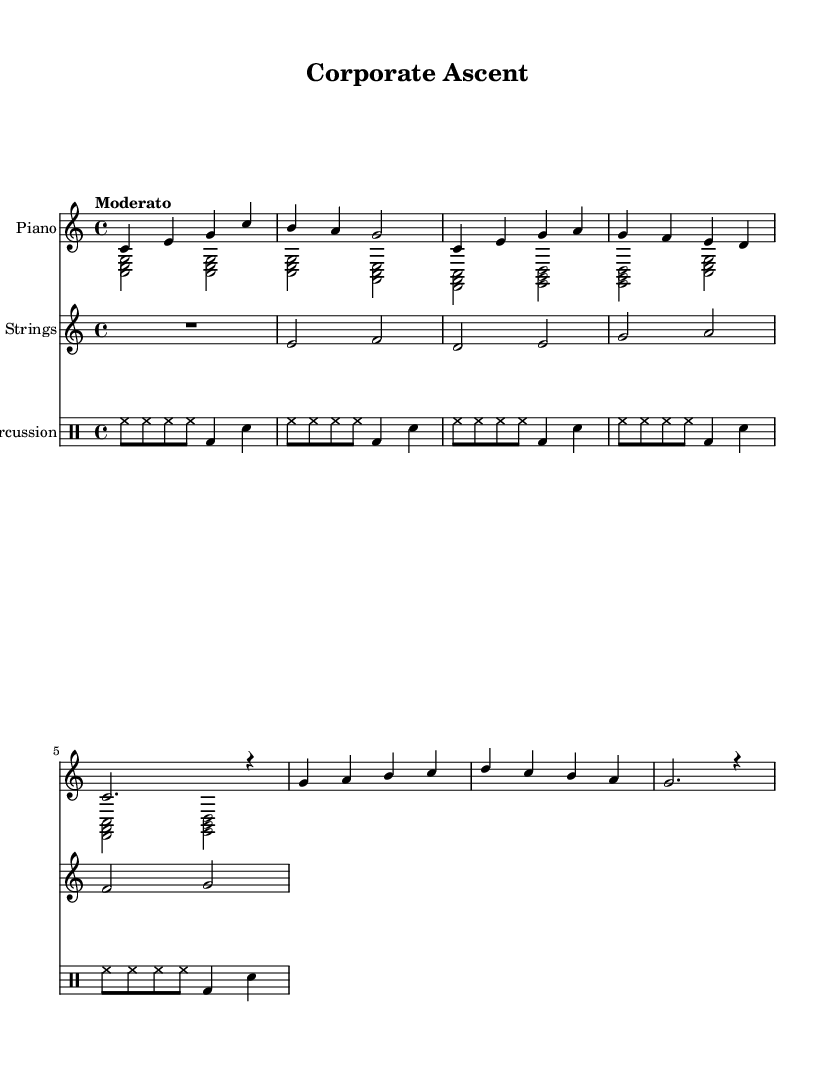What is the key signature of this music? The key signature is indicated at the beginning of the staff where C major is represented, which has no sharps or flats.
Answer: C major What is the time signature of this music? The time signature is shown at the beginning of the staff as 4/4, indicating four beats per measure and a quarter note receives one beat.
Answer: 4/4 What is the tempo marking of this piece? The tempo marking appears at the beginning where it states "Moderato", indicating a moderately paced tempo.
Answer: Moderato How many measures are in the introduction section? The introduction consists of two measures that are clearly indicated before the verse begins, which can be counted in the notation.
Answer: 2 What instruments are used in this piece? The instruments are listed at the beginning of the score as Piano, Strings, and Percussion, which establishes the orchestration of the music.
Answer: Piano, Strings, Percussion Which section has a different rhythmic pattern compared to the others? The introduction has a distinct rhythmic pattern until the verse section starts; looking at the rhythmic notation helps to identify this variation.
Answer: Introduction How many phrases does the chorus contain? The chorus section is comprised of two phrases, which can be determined by analyzing the repeated sections in the notation.
Answer: 2 